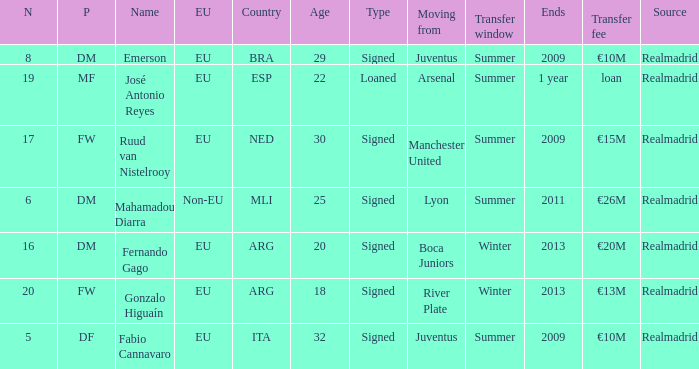How many numbers are ending in 1 year? 1.0. 